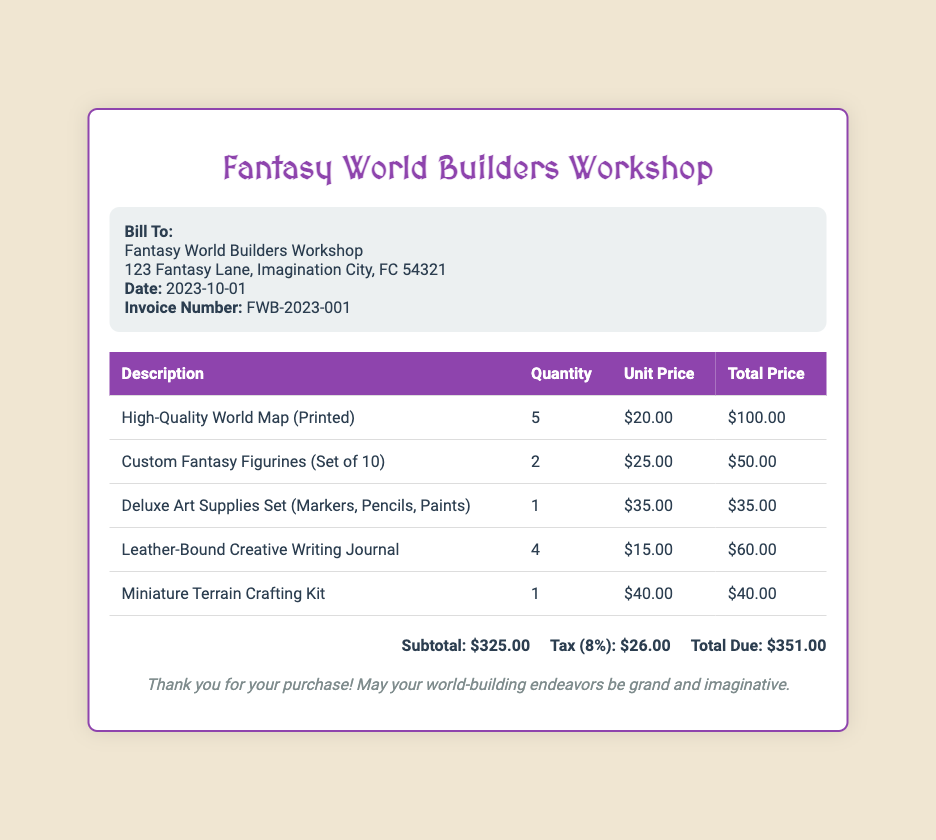How many High-Quality World Maps were purchased? The quantity of High-Quality World Maps is listed in the invoice, which is 5.
Answer: 5 What is the unit price of the Custom Fantasy Figurines? The unit price for the Custom Fantasy Figurines is provided in the document, which is $25.00.
Answer: $25.00 What is the total due amount on the invoice? The total due amount is the value clearly stated at the bottom of the invoice, which is $351.00.
Answer: $351.00 What date was the invoice issued? The invoice date is specifically mentioned under the billing information, which is 2023-10-01.
Answer: 2023-10-01 How many Leather-Bound Creative Writing Journals were ordered? The number of Leather-Bound Creative Writing Journals can be found in the table, where it shows 4 were ordered.
Answer: 4 What is the subtotal amount for the supplies? The subtotal amount is directly indicated in the summary section of the document, which is $325.00.
Answer: $325.00 What type of supplies are included in the Deluxe Art Supplies Set? The specific types of items included in the Deluxe Art Supplies Set are mentioned, which are Markers, Pencils, and Paints.
Answer: Markers, Pencils, Paints What is the tax rate applied to the invoice? The tax percentage applied is noted in the summary section of the invoice, which is 8%.
Answer: 8% What is the invoice number? The invoice number can be found above the billing address, which is FWB-2023-001.
Answer: FWB-2023-001 